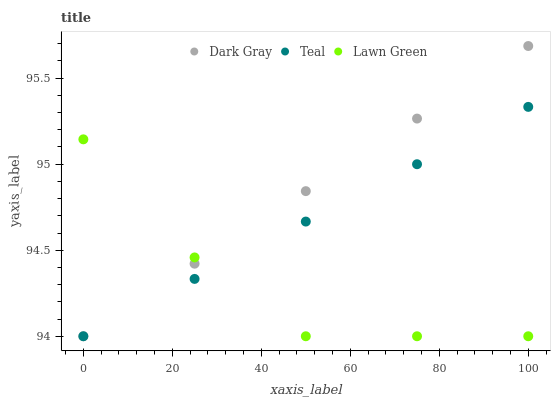Does Lawn Green have the minimum area under the curve?
Answer yes or no. Yes. Does Dark Gray have the maximum area under the curve?
Answer yes or no. Yes. Does Teal have the minimum area under the curve?
Answer yes or no. No. Does Teal have the maximum area under the curve?
Answer yes or no. No. Is Dark Gray the smoothest?
Answer yes or no. Yes. Is Lawn Green the roughest?
Answer yes or no. Yes. Is Teal the smoothest?
Answer yes or no. No. Is Teal the roughest?
Answer yes or no. No. Does Dark Gray have the lowest value?
Answer yes or no. Yes. Does Dark Gray have the highest value?
Answer yes or no. Yes. Does Teal have the highest value?
Answer yes or no. No. Does Dark Gray intersect Teal?
Answer yes or no. Yes. Is Dark Gray less than Teal?
Answer yes or no. No. Is Dark Gray greater than Teal?
Answer yes or no. No. 